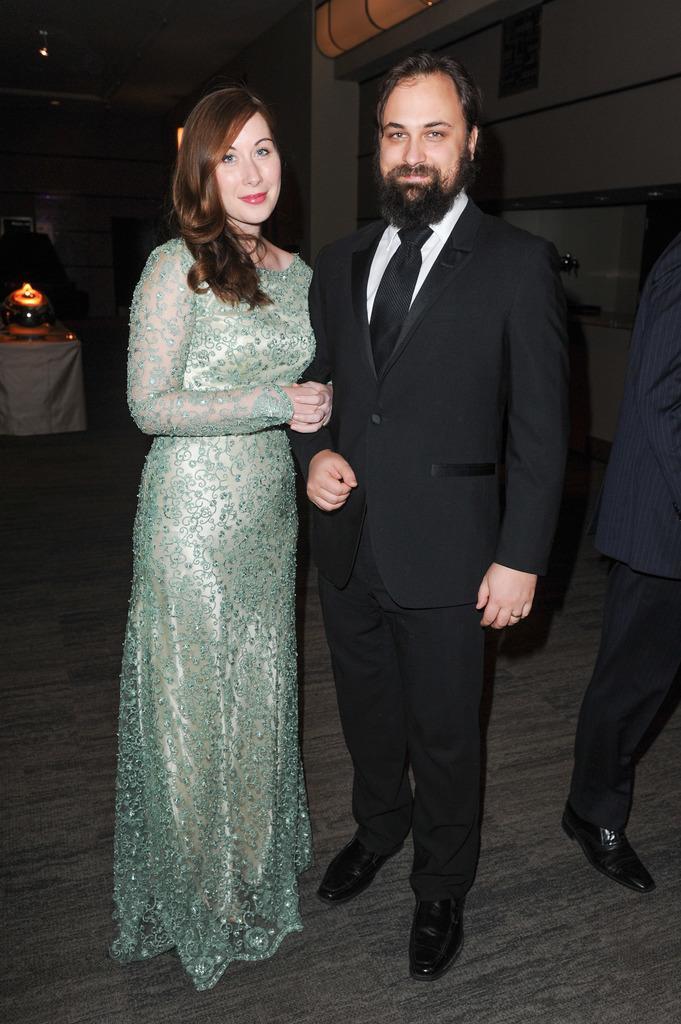Please provide a concise description of this image. In the image there is a man in black suit standing beside a woman in sea green dress on the wooden floor and behind there are few people standing, on the left side there is a table with some dish on it. 